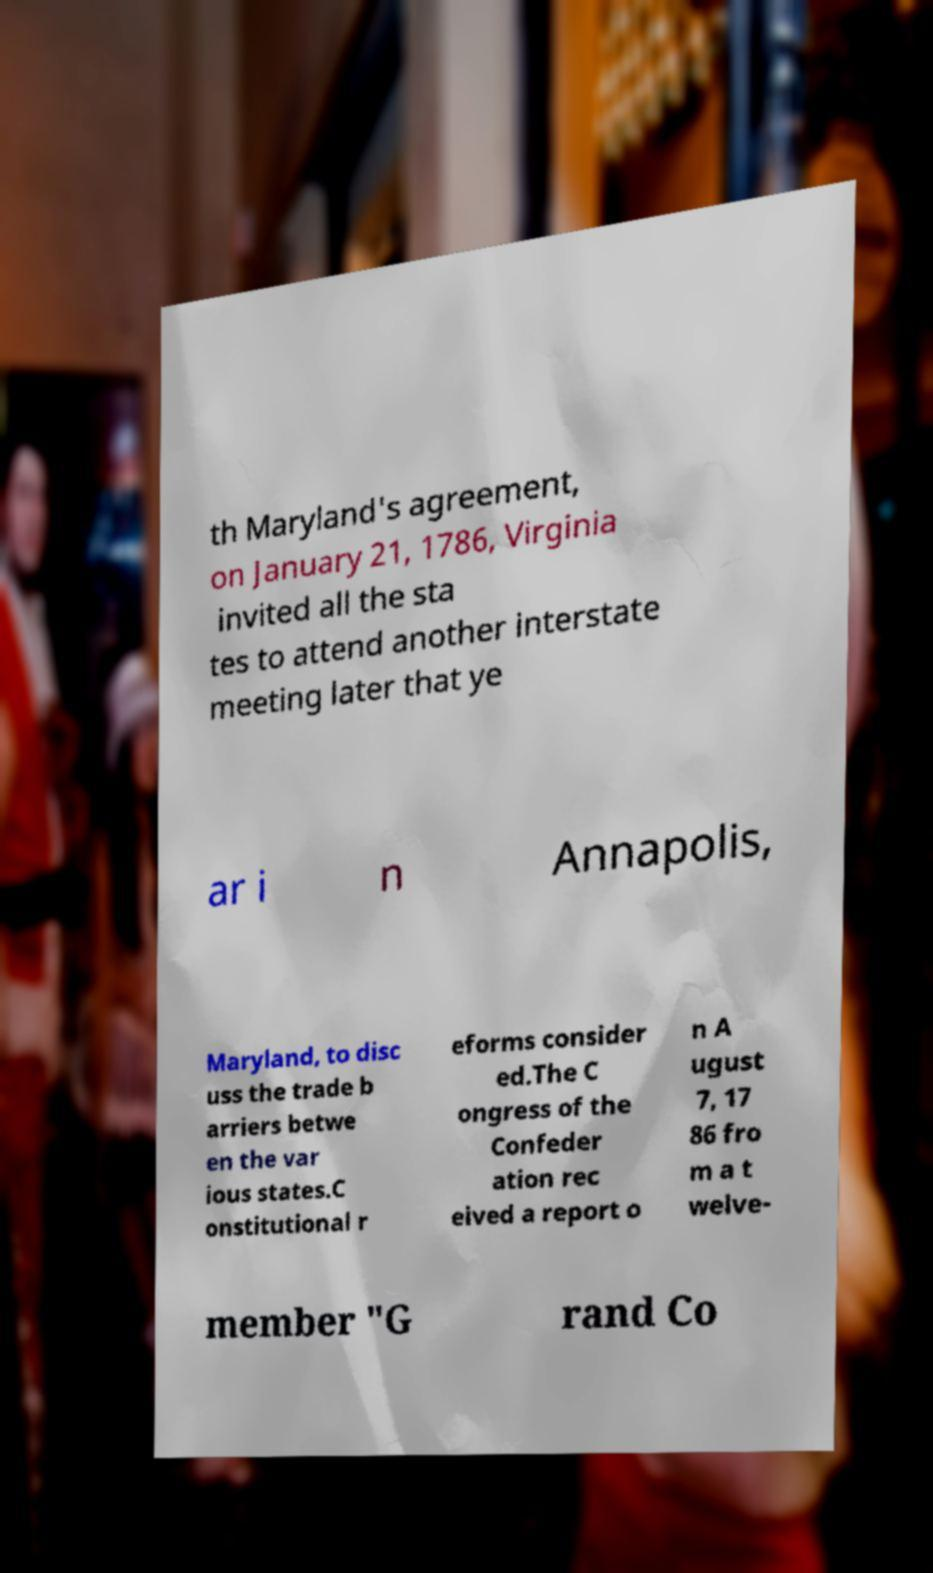I need the written content from this picture converted into text. Can you do that? th Maryland's agreement, on January 21, 1786, Virginia invited all the sta tes to attend another interstate meeting later that ye ar i n Annapolis, Maryland, to disc uss the trade b arriers betwe en the var ious states.C onstitutional r eforms consider ed.The C ongress of the Confeder ation rec eived a report o n A ugust 7, 17 86 fro m a t welve- member "G rand Co 